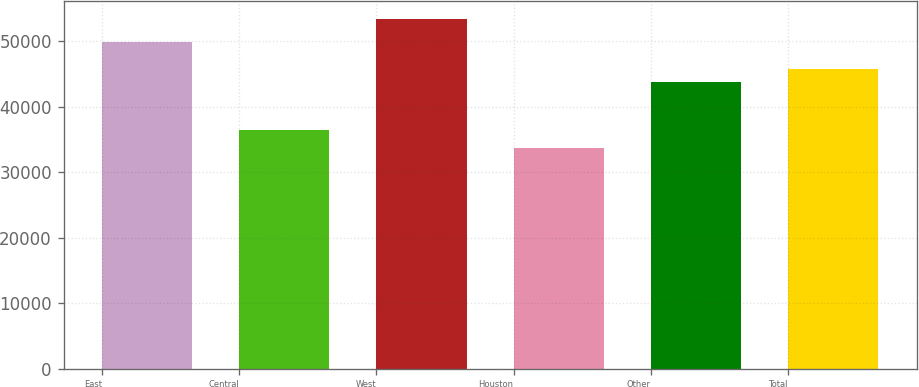<chart> <loc_0><loc_0><loc_500><loc_500><bar_chart><fcel>East<fcel>Central<fcel>West<fcel>Houston<fcel>Other<fcel>Total<nl><fcel>49900<fcel>36400<fcel>53400<fcel>33700<fcel>43800<fcel>45770<nl></chart> 